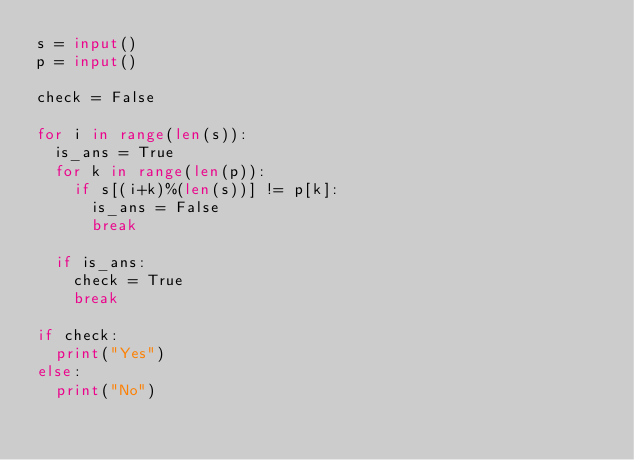<code> <loc_0><loc_0><loc_500><loc_500><_Python_>s = input()
p = input()

check = False

for i in range(len(s)):
  is_ans = True
  for k in range(len(p)):
    if s[(i+k)%(len(s))] != p[k]:
      is_ans = False
      break

  if is_ans:
    check = True
    break

if check:
  print("Yes")
else:
  print("No")
</code> 